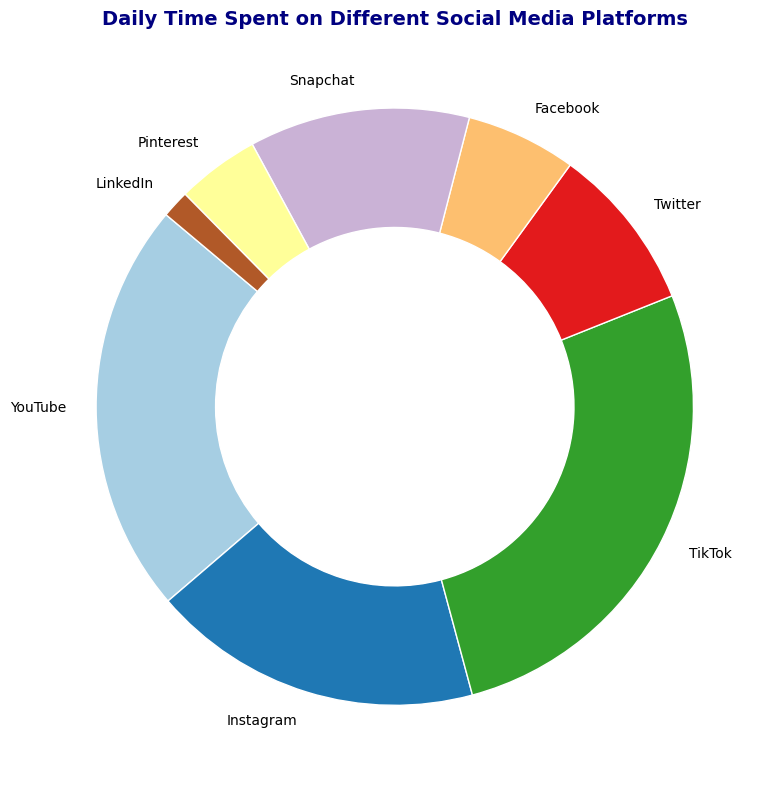What is the total time spent on Facebook, Pinterest, and LinkedIn combined? To find the total time spent on these three platforms, sum their respective times: Facebook (20 minutes) + Pinterest (15 minutes) + LinkedIn (5 minutes). So, 20 + 15 + 5 = 40 minutes.
Answer: 40 minutes Which platform has the highest time spent, and which has the lowest? The platform with the highest time spent is TikTok with 90 minutes. The platform with the lowest time spent is LinkedIn with 5 minutes.
Answer: TikTok and LinkedIn Between Instagram and Twitter, which platform has a higher activity level? Instagram and Twitter both have different activity levels indicated next to their names. Instagram has a "High" activity level, while Twitter has a "Medium" activity level.
Answer: Instagram Among the platforms with high activity levels, which platform has the least time spent? The platforms with high activity levels are YouTube, Instagram, and TikTok. Comparing their times, YouTube (75 minutes), Instagram (60 minutes), and TikTok (90 minutes), Instagram has the least time spent.
Answer: Instagram How much more time is spent on TikTok compared to Facebook? The time spent on TikTok is 90 minutes, and the time spent on Facebook is 20 minutes. Subtracting the two gives 90 - 20 = 70 minutes.
Answer: 70 minutes What percentage of the total time spent is attributed to YouTube? First, find the total time spent on all platforms. Adding all times: 75 + 60 + 90 + 30 + 20 + 40 + 15 + 5 = 335 minutes. The percentage for YouTube is then (75 / 335) * 100 ≈ 22.39%.
Answer: 22.39% Which two platforms together make up more than 50% of the total time spent? From the pie chart, the largest time spent is on TikTok (90 minutes) and YouTube (75 minutes). Together, they account for 90 + 75 = 165 minutes. Checking the total time, which is 335 minutes, 165 / 335 * 100 ≈ 49.25%. Therefore, TikTok and Instagram (90 + 60 = 150 minutes) don't add up to more than 50%, but TikTok and YouTube with 90 + 75 = 165 minutes nearly do. Combined, TikTok and Instagram also exceed 50%: 150/335 * 100 ≈ 44.78%, which is less. Hence, no pair of two platforms matches the query directly.
Answer: None How much more time do people spend on Snapchat compared to LinkedIn? The time spent on Snapchat is 40 minutes, and the time spent on LinkedIn is 5 minutes. Subtracting the two gives 40 - 5 = 35 minutes.
Answer: 35 minutes If the total time spent on social media is one day (1440 minutes), what fraction of the total day is spent on Instagram? Instagram time spent is 60 minutes. If the total day is 1440 minutes, the fraction is 60 / 1440 = 1/24.
Answer: 1/24 What’s the difference in time spent between the highest activity level platform and the lowest activity level platform? The highest activity level platform is TikTok with 90 minutes, and the lowest activity level platform is LinkedIn with 5 minutes. The difference is 90 - 5 = 85 minutes.
Answer: 85 minutes 